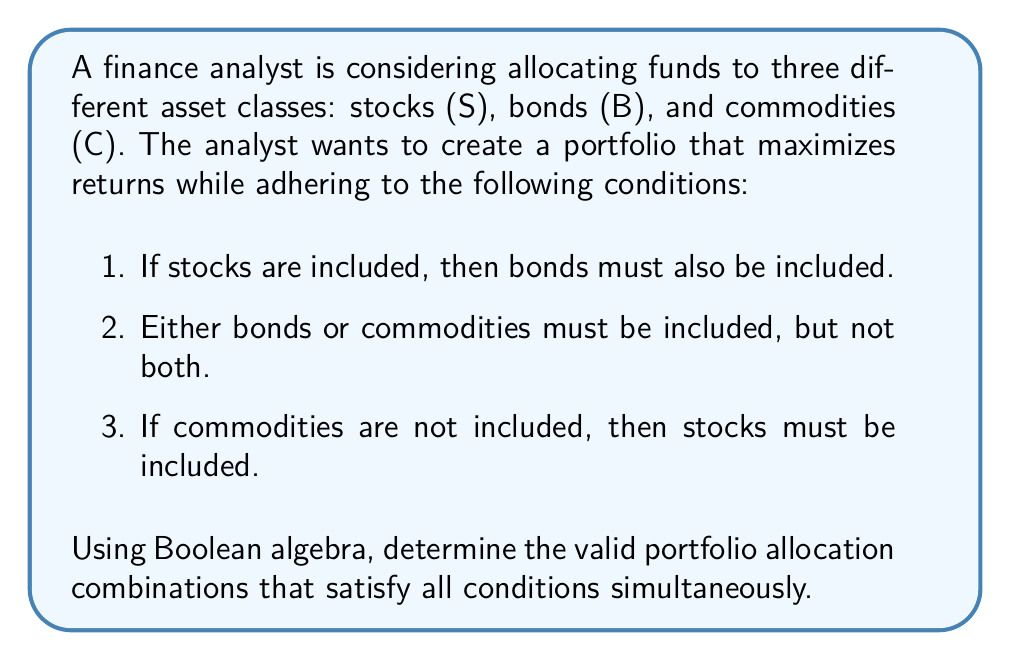Solve this math problem. Let's approach this problem using Boolean algebra:

1. Define variables:
   S: Stocks are included (1 if true, 0 if false)
   B: Bonds are included (1 if true, 0 if false)
   C: Commodities are included (1 if true, 0 if false)

2. Translate conditions into Boolean expressions:
   Condition 1: $S \implies B$ (If S then B)
   Condition 2: $B \oplus C$ (B XOR C)
   Condition 3: $\overline{C} \implies S$ (If not C then S)

3. Combine conditions using logical AND:
   $$(S \implies B) \land (B \oplus C) \land (\overline{C} \implies S)$$

4. Convert implications to disjunctions:
   $$(\overline{S} \lor B) \land (B \oplus C) \land (C \lor S)$$

5. Expand XOR operation:
   $$(\overline{S} \lor B) \land ((B \land \overline{C}) \lor (\overline{B} \land C)) \land (C \lor S)$$

6. Use distributive property to expand:
   $$(\overline{S} \lor B) \land (B \land \overline{C} \lor \overline{B} \land C) \land (C \lor S)$$

7. Create truth table to evaluate all possible combinations:

   | S | B | C | $\overline{S} \lor B$ | $B \land \overline{C} \lor \overline{B} \land C$ | $C \lor S$ | Result |
   |---|---|---|---------------------|-----------------------------------------------|------------|--------|
   | 0 | 0 | 0 | 1                   | 0                                             | 0          | 0      |
   | 0 | 0 | 1 | 1                   | 1                                             | 1          | 1      |
   | 0 | 1 | 0 | 1                   | 1                                             | 0          | 0      |
   | 0 | 1 | 1 | 1                   | 0                                             | 1          | 0      |
   | 1 | 0 | 0 | 0                   | 0                                             | 1          | 0      |
   | 1 | 0 | 1 | 0                   | 1                                             | 1          | 0      |
   | 1 | 1 | 0 | 1                   | 1                                             | 1          | 1      |
   | 1 | 1 | 1 | 1                   | 0                                             | 1          | 0      |

8. Identify valid combinations from the truth table:
   - (0, 0, 1): No stocks, no bonds, include commodities
   - (1, 1, 0): Include stocks, include bonds, no commodities
Answer: The valid portfolio allocation combinations that satisfy all conditions are:
1. Commodities only (C)
2. Stocks and Bonds (S, B) 